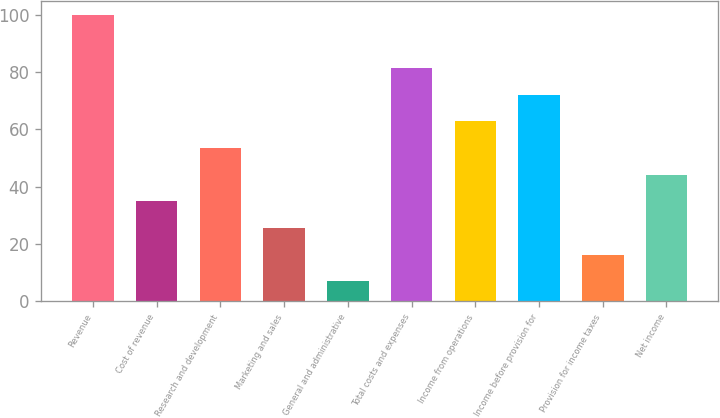Convert chart. <chart><loc_0><loc_0><loc_500><loc_500><bar_chart><fcel>Revenue<fcel>Cost of revenue<fcel>Research and development<fcel>Marketing and sales<fcel>General and administrative<fcel>Total costs and expenses<fcel>Income from operations<fcel>Income before provision for<fcel>Provision for income taxes<fcel>Net income<nl><fcel>100<fcel>34.9<fcel>53.5<fcel>25.6<fcel>7<fcel>81.4<fcel>62.8<fcel>72.1<fcel>16.3<fcel>44.2<nl></chart> 